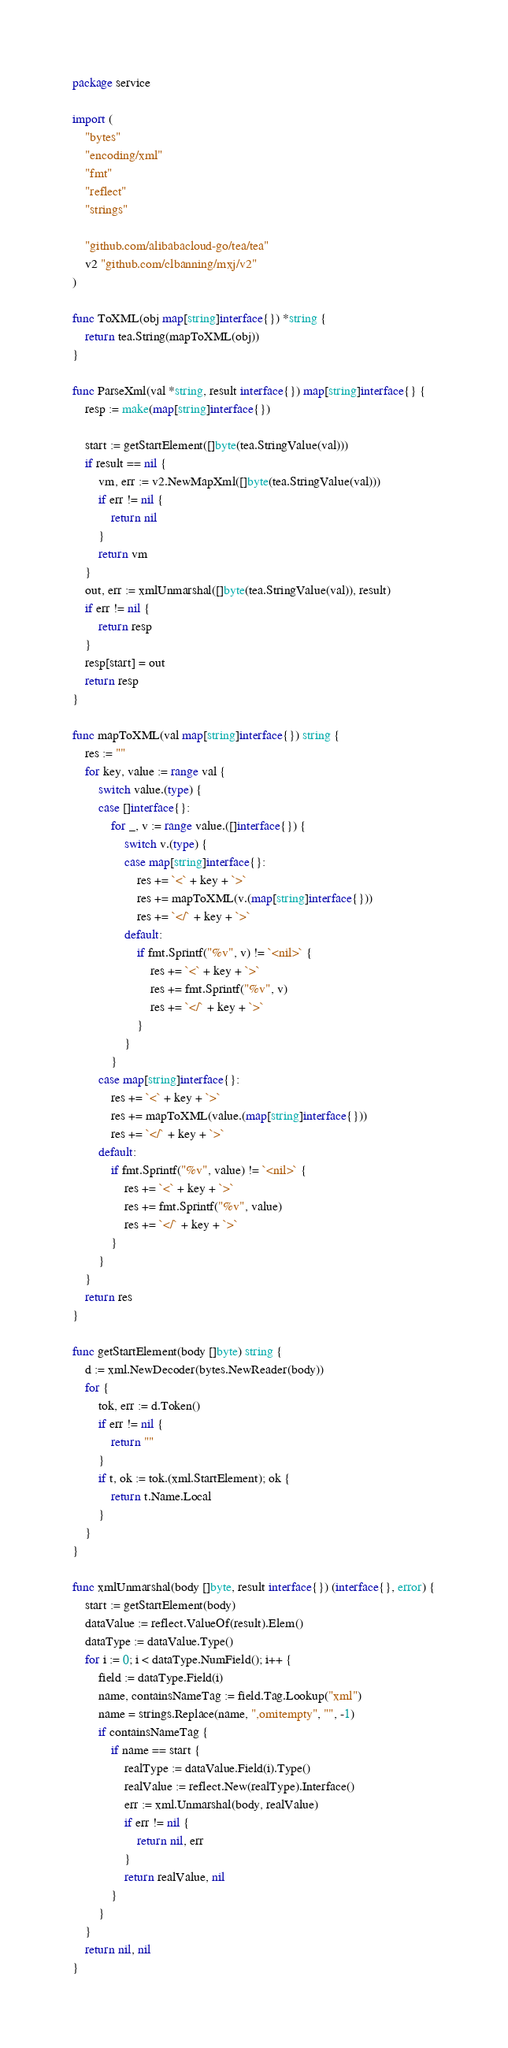Convert code to text. <code><loc_0><loc_0><loc_500><loc_500><_Go_>package service

import (
	"bytes"
	"encoding/xml"
	"fmt"
	"reflect"
	"strings"

	"github.com/alibabacloud-go/tea/tea"
	v2 "github.com/clbanning/mxj/v2"
)

func ToXML(obj map[string]interface{}) *string {
	return tea.String(mapToXML(obj))
}

func ParseXml(val *string, result interface{}) map[string]interface{} {
	resp := make(map[string]interface{})

	start := getStartElement([]byte(tea.StringValue(val)))
	if result == nil {
		vm, err := v2.NewMapXml([]byte(tea.StringValue(val)))
		if err != nil {
			return nil
		}
		return vm
	}
	out, err := xmlUnmarshal([]byte(tea.StringValue(val)), result)
	if err != nil {
		return resp
	}
	resp[start] = out
	return resp
}

func mapToXML(val map[string]interface{}) string {
	res := ""
	for key, value := range val {
		switch value.(type) {
		case []interface{}:
			for _, v := range value.([]interface{}) {
				switch v.(type) {
				case map[string]interface{}:
					res += `<` + key + `>`
					res += mapToXML(v.(map[string]interface{}))
					res += `</` + key + `>`
				default:
					if fmt.Sprintf("%v", v) != `<nil>` {
						res += `<` + key + `>`
						res += fmt.Sprintf("%v", v)
						res += `</` + key + `>`
					}
				}
			}
		case map[string]interface{}:
			res += `<` + key + `>`
			res += mapToXML(value.(map[string]interface{}))
			res += `</` + key + `>`
		default:
			if fmt.Sprintf("%v", value) != `<nil>` {
				res += `<` + key + `>`
				res += fmt.Sprintf("%v", value)
				res += `</` + key + `>`
			}
		}
	}
	return res
}

func getStartElement(body []byte) string {
	d := xml.NewDecoder(bytes.NewReader(body))
	for {
		tok, err := d.Token()
		if err != nil {
			return ""
		}
		if t, ok := tok.(xml.StartElement); ok {
			return t.Name.Local
		}
	}
}

func xmlUnmarshal(body []byte, result interface{}) (interface{}, error) {
	start := getStartElement(body)
	dataValue := reflect.ValueOf(result).Elem()
	dataType := dataValue.Type()
	for i := 0; i < dataType.NumField(); i++ {
		field := dataType.Field(i)
		name, containsNameTag := field.Tag.Lookup("xml")
		name = strings.Replace(name, ",omitempty", "", -1)
		if containsNameTag {
			if name == start {
				realType := dataValue.Field(i).Type()
				realValue := reflect.New(realType).Interface()
				err := xml.Unmarshal(body, realValue)
				if err != nil {
					return nil, err
				}
				return realValue, nil
			}
		}
	}
	return nil, nil
}
</code> 